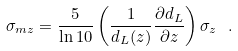<formula> <loc_0><loc_0><loc_500><loc_500>\sigma _ { m z } = \frac { 5 } { \ln { 1 0 } } \left ( \frac { 1 } { d _ { L } ( z ) } \frac { \partial { d _ { L } } } { \partial { z } } \right ) \sigma _ { z } \ .</formula> 